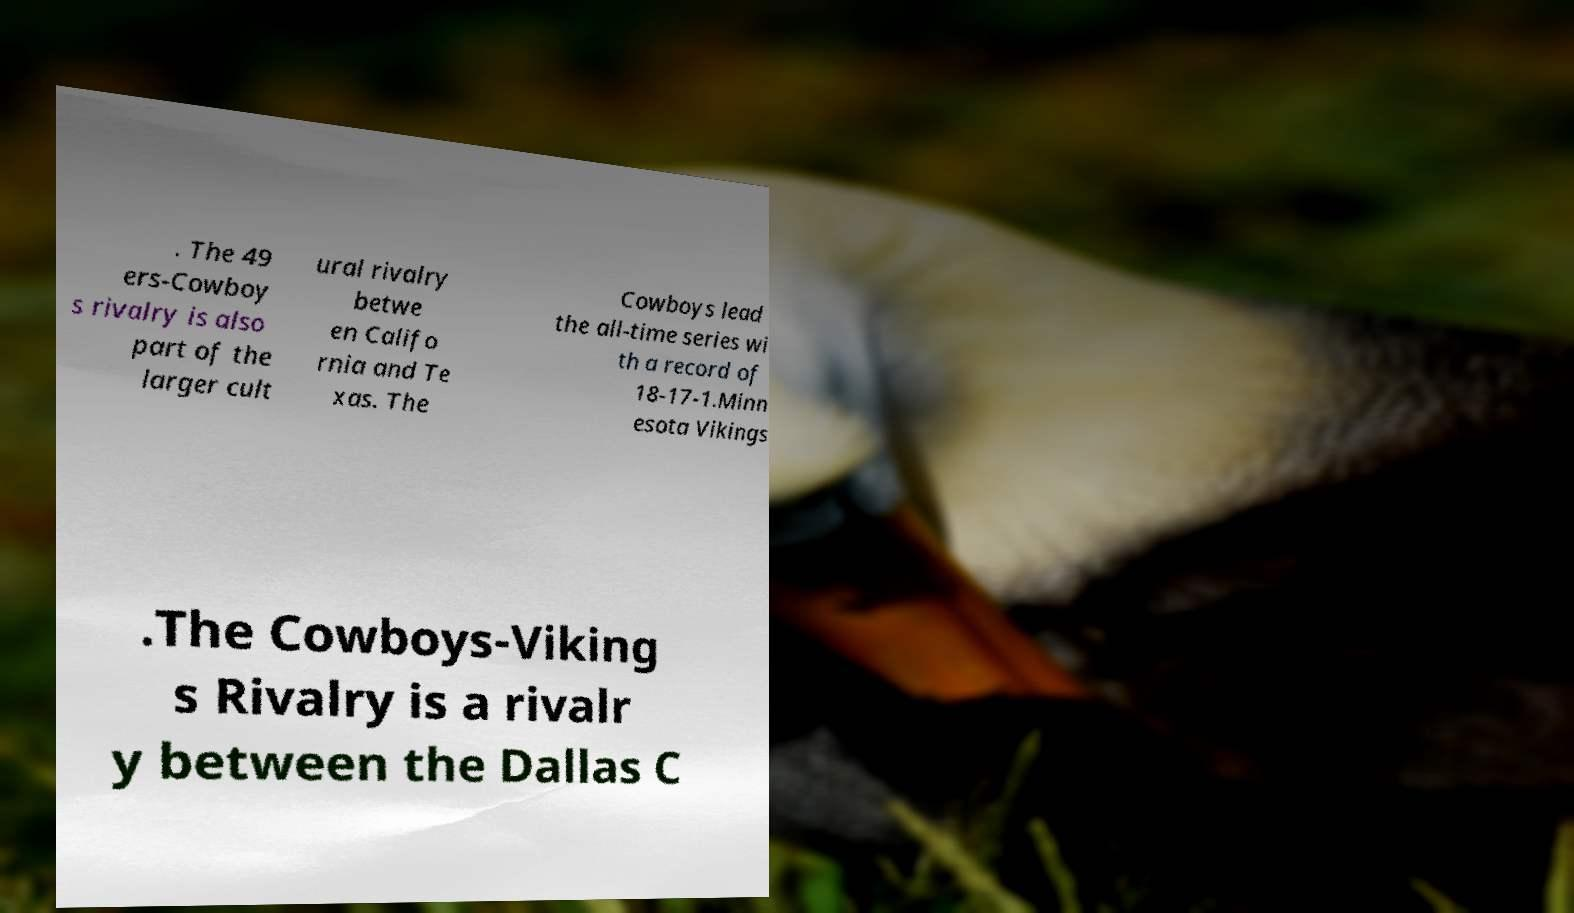What messages or text are displayed in this image? I need them in a readable, typed format. . The 49 ers-Cowboy s rivalry is also part of the larger cult ural rivalry betwe en Califo rnia and Te xas. The Cowboys lead the all-time series wi th a record of 18-17-1.Minn esota Vikings .The Cowboys-Viking s Rivalry is a rivalr y between the Dallas C 